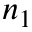Convert formula to latex. <formula><loc_0><loc_0><loc_500><loc_500>n _ { 1 }</formula> 